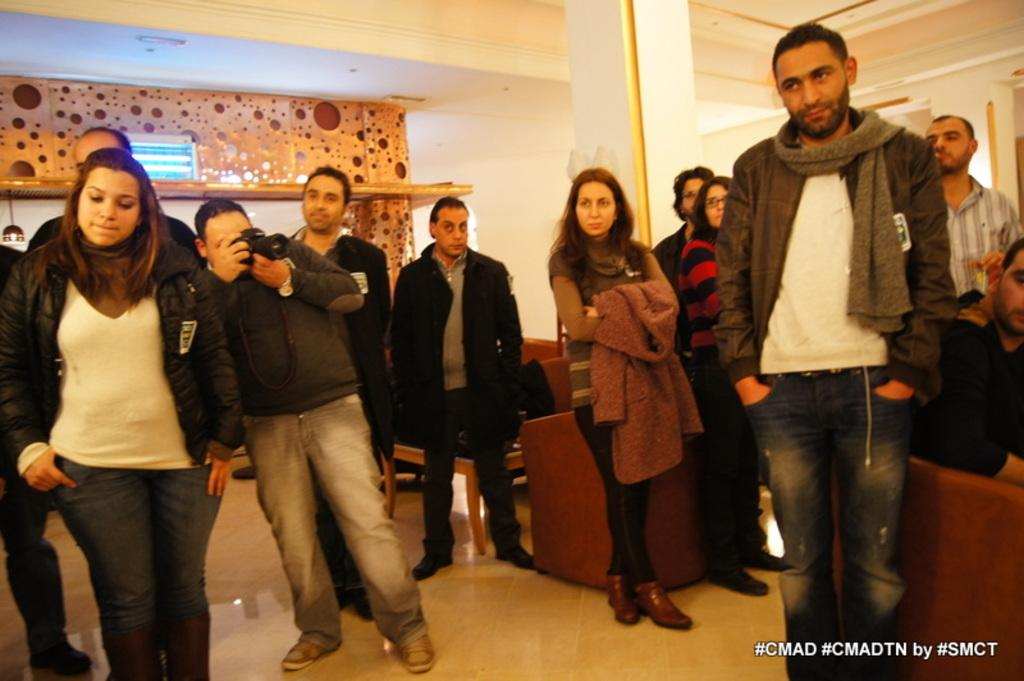<image>
Render a clear and concise summary of the photo. Several people of different ages are standing around in a room, in a photo taged #CMAD #CMADTN by #SMCT. 